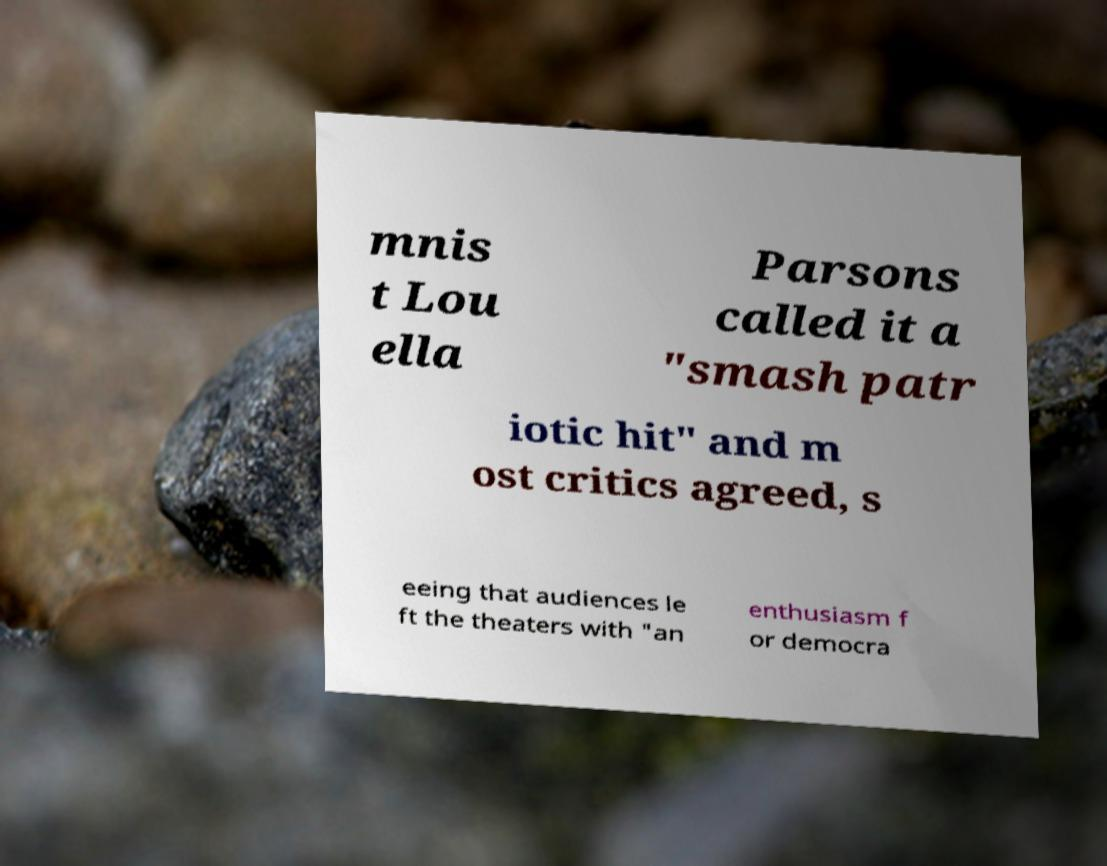Can you accurately transcribe the text from the provided image for me? mnis t Lou ella Parsons called it a "smash patr iotic hit" and m ost critics agreed, s eeing that audiences le ft the theaters with "an enthusiasm f or democra 